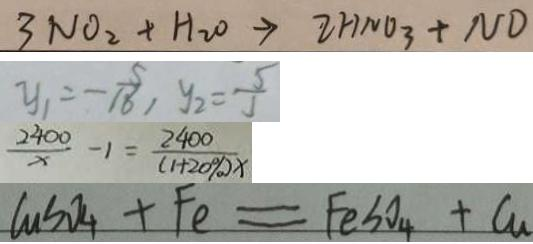<formula> <loc_0><loc_0><loc_500><loc_500>3 N O _ { 2 } + H _ { 2 } O \rightarrow 2 H N O _ { 3 } + N D 
 y _ { 1 } = - \frac { 5 } { 1 8 6 } , y _ { 2 } = \frac { 5 } { 5 } 
 \frac { 2 4 0 0 } { x } - 1 = \frac { 2 4 0 0 } { ( 1 + 2 0 \% ) x } 
 C u S O _ { 4 } + F e = F e S O _ { 4 } + C u</formula> 